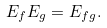<formula> <loc_0><loc_0><loc_500><loc_500>E _ { f } E _ { g } = E _ { f g } .</formula> 